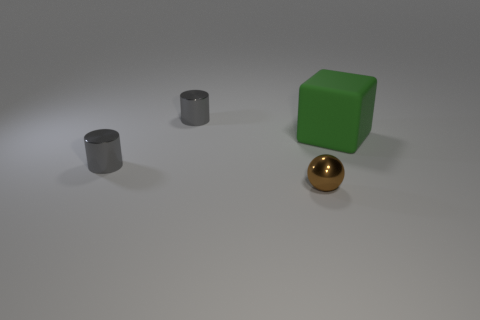What shape is the thing that is to the right of the small brown ball?
Your response must be concise. Cube. Are there any gray things of the same size as the brown shiny sphere?
Keep it short and to the point. Yes. What is the size of the shiny cylinder in front of the green matte object?
Provide a short and direct response. Small. What is the size of the matte thing?
Your answer should be very brief. Large. Does the brown sphere have the same size as the thing on the right side of the small brown metallic object?
Make the answer very short. No. The small cylinder that is behind the thing on the right side of the tiny brown object is what color?
Make the answer very short. Gray. Are there an equal number of matte blocks that are in front of the shiny sphere and tiny things behind the green cube?
Give a very brief answer. No. Are the tiny object that is behind the large green matte block and the small sphere made of the same material?
Your answer should be very brief. Yes. There is a small metallic object that is both to the left of the ball and in front of the green cube; what is its color?
Ensure brevity in your answer.  Gray. There is a gray cylinder that is behind the large green rubber object; how many tiny metallic cylinders are right of it?
Ensure brevity in your answer.  0. 